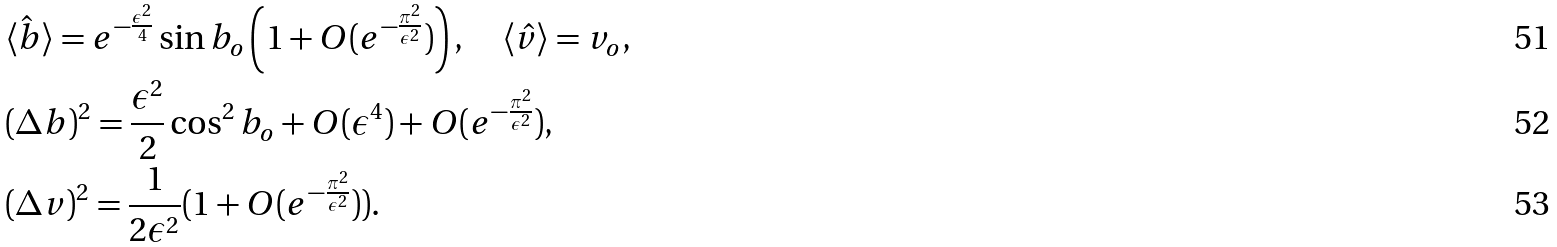<formula> <loc_0><loc_0><loc_500><loc_500>& \langle { \hat { b } } \rangle = e ^ { - \frac { \epsilon ^ { 2 } } { 4 } } \sin b _ { o } \left ( 1 + O ( e ^ { - \frac { \pi ^ { 2 } } { \epsilon ^ { 2 } } } ) \right ) , \quad \langle \hat { v } \rangle = v _ { o } , \\ & ( \Delta b ) ^ { 2 } = \frac { \epsilon ^ { 2 } } { 2 } \cos ^ { 2 } b _ { o } + O ( \epsilon ^ { 4 } ) + O ( e ^ { - \frac { \pi ^ { 2 } } { \epsilon ^ { 2 } } } ) , \\ & ( \Delta v ) ^ { 2 } = \frac { 1 } { 2 \epsilon ^ { 2 } } ( 1 + O ( e ^ { - \frac { \pi ^ { 2 } } { \epsilon ^ { 2 } } } ) ) .</formula> 